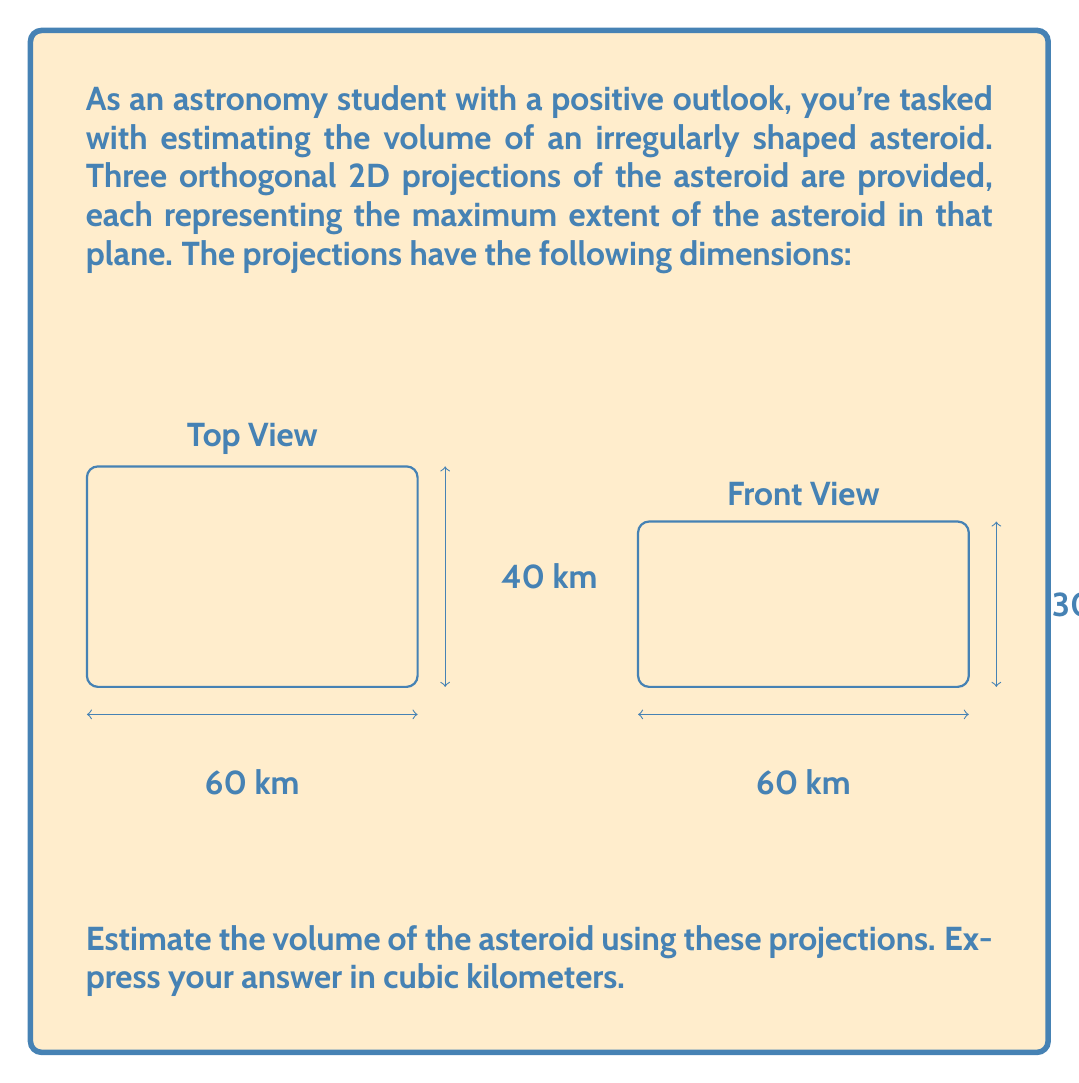Could you help me with this problem? To estimate the volume of an irregular asteroid using 2D projections, we can use the following approach:

1) First, we identify the maximum dimensions from each projection:
   Length (L) = 60 km (from top and front views)
   Width (W) = 40 km (from top and side views)
   Height (H) = 30 km (from front and side views)

2) The simplest estimate would be to calculate the volume of a rectangular prism with these dimensions:

   $$V_{rect} = L \times W \times H = 60 \times 40 \times 30 = 72,000 \text{ km}^3$$

3) However, this likely overestimates the volume as the asteroid is irregular. A more realistic estimate can be obtained by multiplying this volume by a shape factor. For irregularly shaped asteroids, a common shape factor is approximately 0.25 to 0.5.

4) Let's use a shape factor of 0.4 for this estimation:

   $$V_{est} = 0.4 \times V_{rect} = 0.4 \times 72,000 = 28,800 \text{ km}^3$$

5) Rounding to two significant figures (as this is an estimate):

   $$V_{est} \approx 29,000 \text{ km}^3$$

This method provides a reasonable estimate of the asteroid's volume based on the given 2D projections, while accounting for its irregular shape.
Answer: $29,000 \text{ km}^3$ 